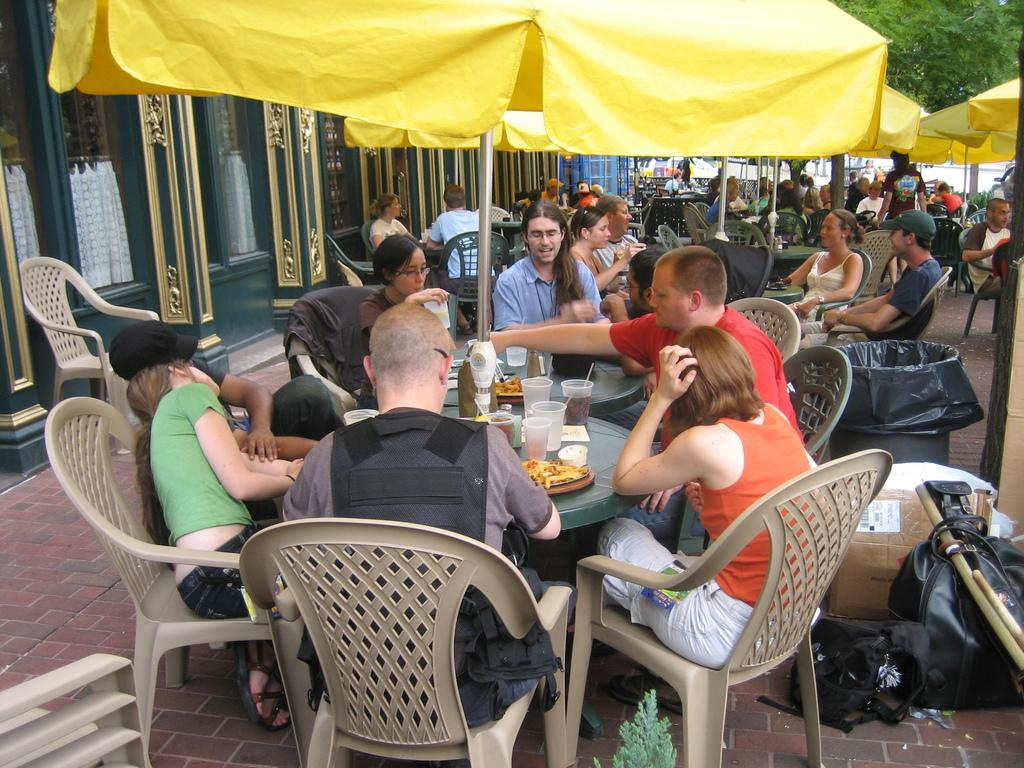How many people are in the image? There is a group of people in the image, but the exact number is not specified. What are the people doing in the image? The people are sitting on chairs in the image. What is in front of the people? There is a table in front of the people. What is happening at the table? The people are having food on the table. What type of sign can be seen on the table in the image? There is no sign present on the table in the image. What is the color of the lipstick worn by the people in the image? There is no mention of lipstick or any cosmetics in the image. 